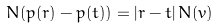<formula> <loc_0><loc_0><loc_500><loc_500>N ( p ( r ) - p ( t ) ) = | r - t | \, N ( v )</formula> 